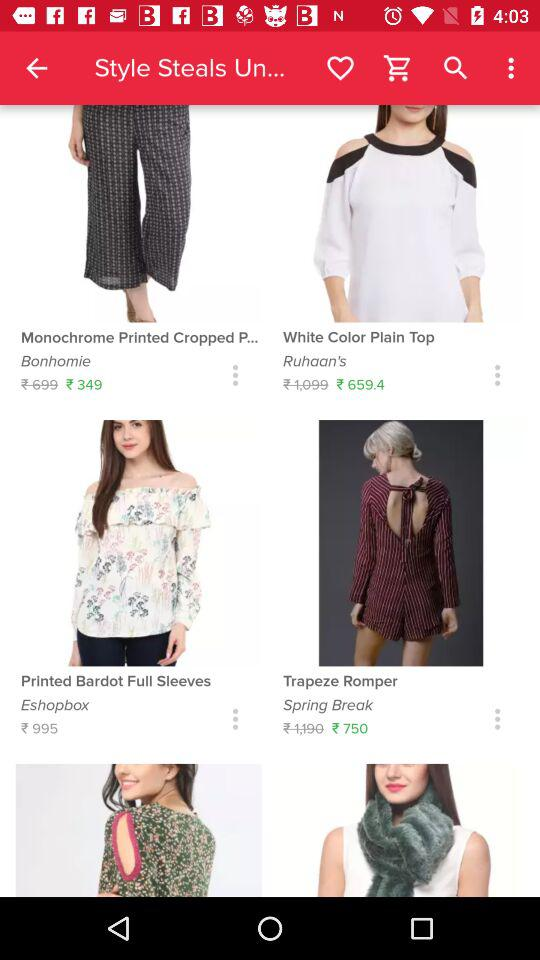What is the brand name of "White Color Plain Top"? The brand name of "White Color Plain Top" is "Ruhaan's". 